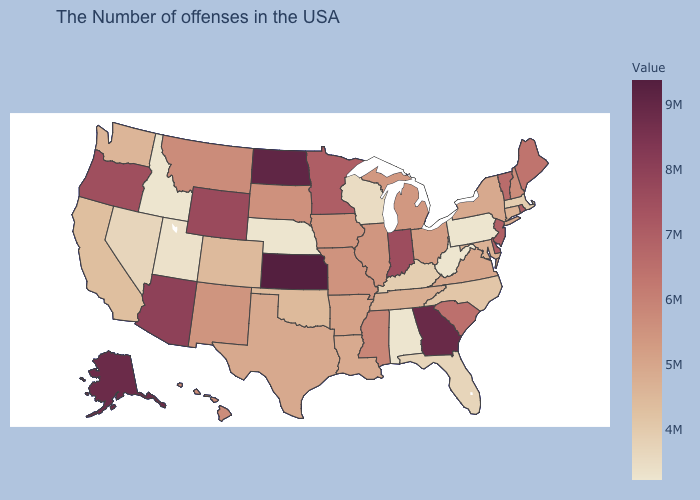Among the states that border Montana , which have the highest value?
Write a very short answer. North Dakota. Among the states that border Maryland , which have the highest value?
Concise answer only. Delaware. Which states have the lowest value in the USA?
Write a very short answer. Pennsylvania, West Virginia, Alabama, Nebraska, Idaho. Does Alaska have the highest value in the West?
Keep it brief. Yes. Among the states that border New York , which have the lowest value?
Give a very brief answer. Pennsylvania. Is the legend a continuous bar?
Keep it brief. Yes. 